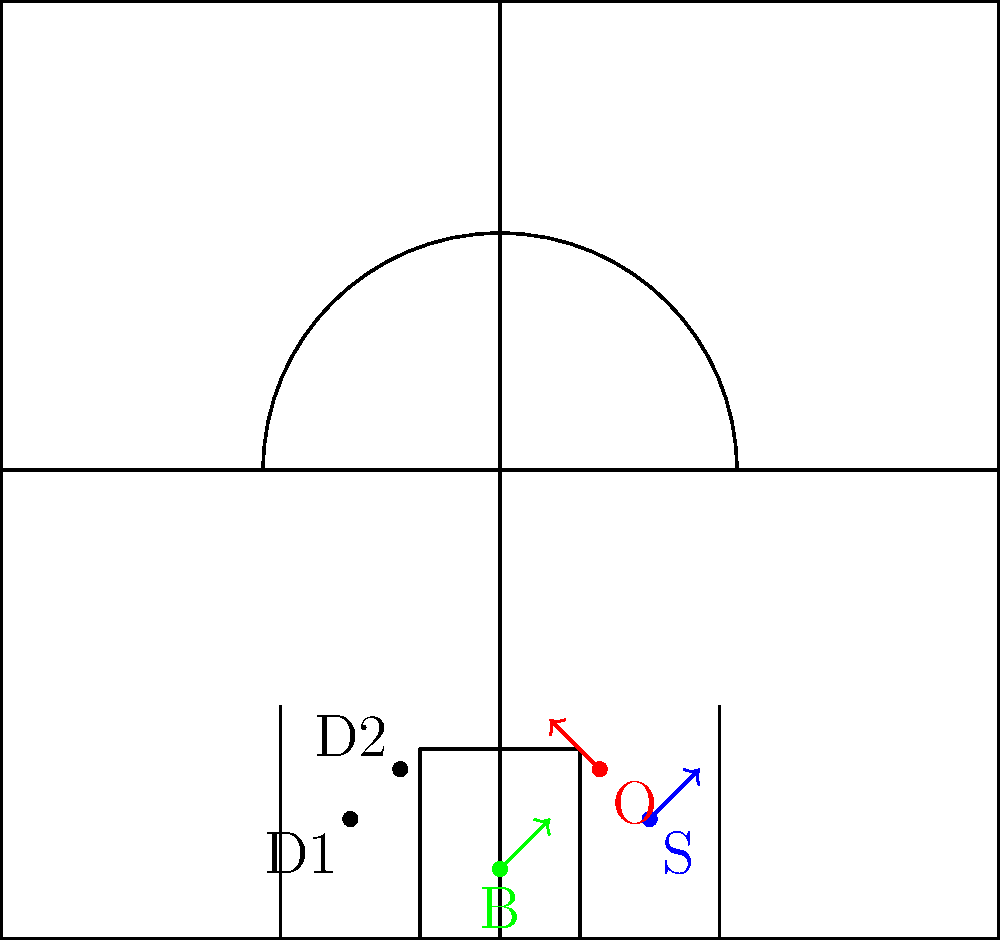In the diagram above, a pick-and-roll play is shown with offensive players (O - ball handler, S - screen setter, B - roller) and defensive players (D1 and D2). Which traditional defensive scheme would be most effective against this pick-and-roll setup, and why?

A) Ice defense
B) Drop coverage
C) Hedge defense
D) Switch defense To answer this question, let's analyze each defensive scheme:

1. Ice defense: This involves the on-ball defender forcing the ball handler towards the sideline, away from the middle. In this scenario, it's not ideal as the ball handler (O) is already on the wing.

2. Drop coverage: In this scheme, D2 would drop back to protect the paint while D1 fights through the screen. This could be effective, but it might leave the ball handler open for a mid-range shot.

3. Hedge defense: Here, D2 would temporarily step out to impede the ball handler's progress, giving D1 time to recover. This aggressive approach can disrupt the offense's timing and force a reset.

4. Switch defense: D1 and D2 would simply switch assignments, with D1 picking up the roller (B) and D2 guarding the ball handler (O). While effective in some situations, it can create mismatches.

Given the traditional coaching perspective and the setup shown, the hedge defense (option C) would be most effective. It maintains defensive pressure on the ball handler, disrupts the offensive flow, and doesn't create potential mismatches. This approach aligns with traditional coaching philosophies that emphasize aggressive defense and protecting against easy baskets.
Answer: C) Hedge defense 